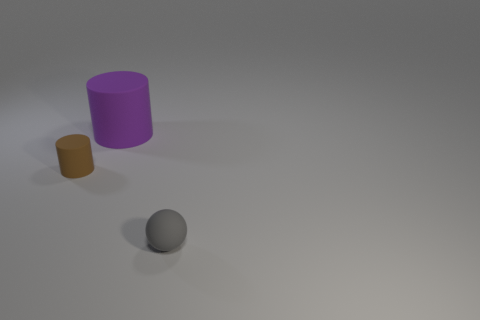There is a brown cylinder that is the same material as the gray ball; what is its size?
Your answer should be compact. Small. There is a rubber thing that is in front of the big purple matte thing and to the right of the tiny cylinder; what is its shape?
Ensure brevity in your answer.  Sphere. There is a matte thing that is left of the rubber cylinder that is behind the tiny brown rubber object; what is its size?
Offer a terse response. Small. What number of other things are the same color as the small ball?
Your response must be concise. 0. What is the large purple cylinder made of?
Ensure brevity in your answer.  Rubber. Are there any balls?
Ensure brevity in your answer.  Yes. Are there the same number of big objects that are behind the purple cylinder and tiny rubber cylinders?
Your response must be concise. No. How many small things are either cylinders or purple metal cylinders?
Provide a short and direct response. 1. Is the material of the cylinder behind the brown rubber thing the same as the small cylinder?
Your response must be concise. Yes. There is a tiny object behind the tiny thing that is in front of the tiny cylinder; what is it made of?
Provide a short and direct response. Rubber. 